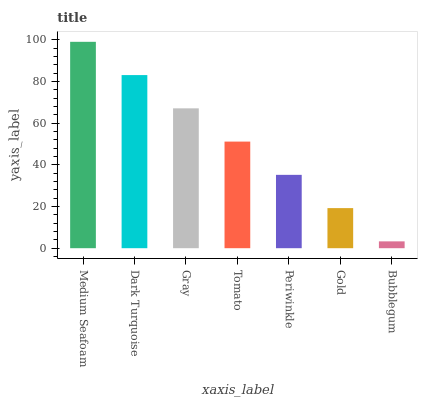Is Bubblegum the minimum?
Answer yes or no. Yes. Is Medium Seafoam the maximum?
Answer yes or no. Yes. Is Dark Turquoise the minimum?
Answer yes or no. No. Is Dark Turquoise the maximum?
Answer yes or no. No. Is Medium Seafoam greater than Dark Turquoise?
Answer yes or no. Yes. Is Dark Turquoise less than Medium Seafoam?
Answer yes or no. Yes. Is Dark Turquoise greater than Medium Seafoam?
Answer yes or no. No. Is Medium Seafoam less than Dark Turquoise?
Answer yes or no. No. Is Tomato the high median?
Answer yes or no. Yes. Is Tomato the low median?
Answer yes or no. Yes. Is Bubblegum the high median?
Answer yes or no. No. Is Gold the low median?
Answer yes or no. No. 